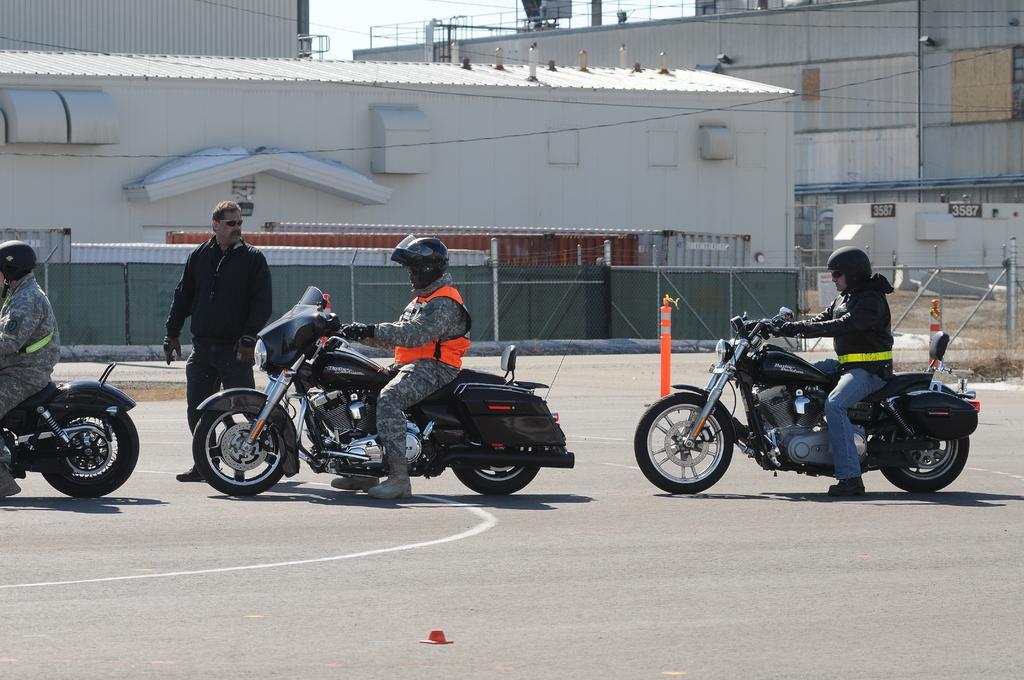Please provide a concise description of this image. In this picture outside of the shed. The three persons are riding on a motorcycle. They are wearing helmet. On the left side of the person is standing,He is wearing spectacle. We can see in background wall,fence,sky. 